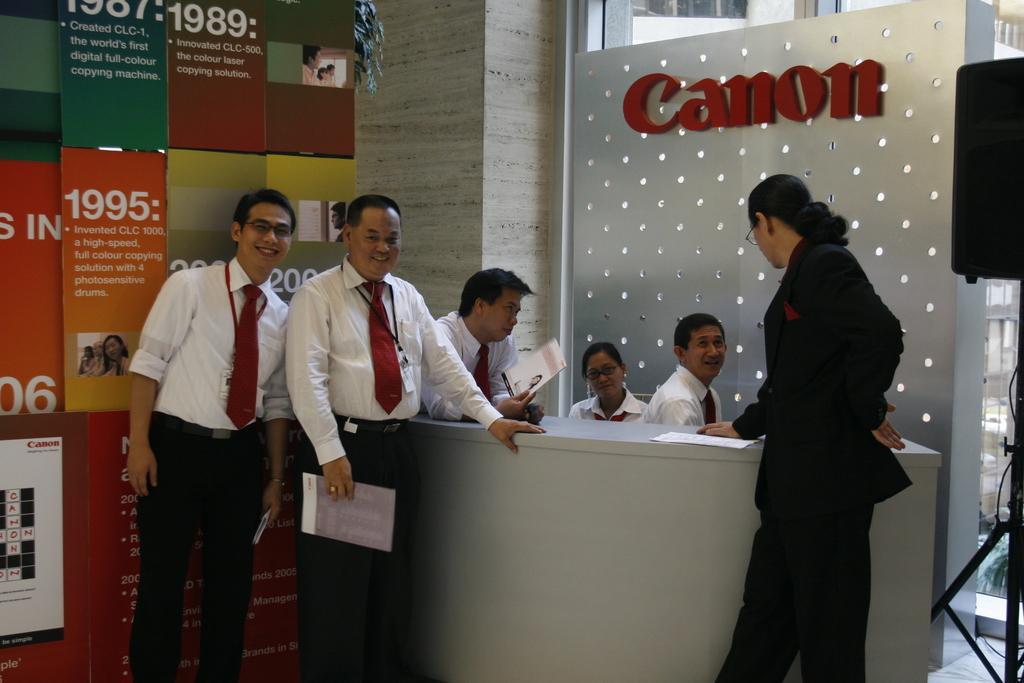Describe this image in one or two sentences. In this image there are six people. Two women and four men. In the background there is stand on which it is written as cannon. To the left the men are wearing white shirt and black pant with red tie. To the right the woman is wearing black color dress. 